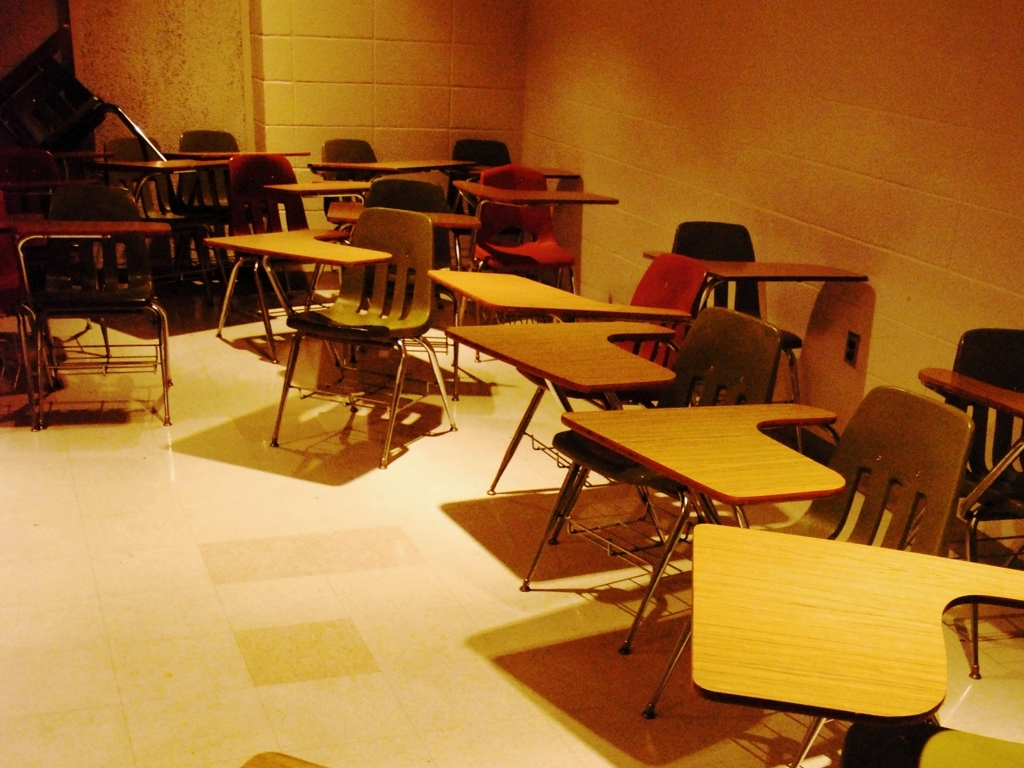What does the variety of chair colors in the classroom suggest about the setting? The variety of chair colors in the classroom could suggest a more informal setting or creative environment. Different colors might have been introduced to enliven the space or for easy classification of seating, although the disarray of the chairs somewhat diminishes this effect. 